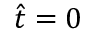<formula> <loc_0><loc_0><loc_500><loc_500>\hat { t } = 0</formula> 